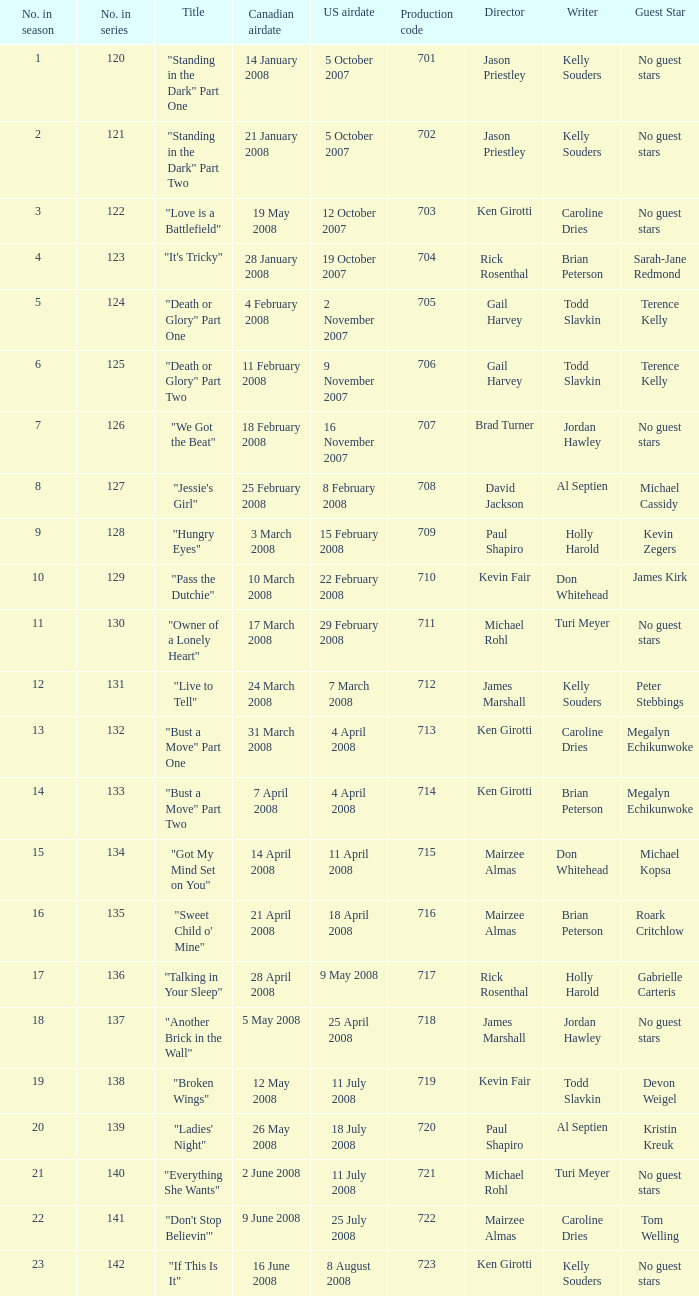The canadian airdate of 17 march 2008 had how many numbers in the season? 1.0. 